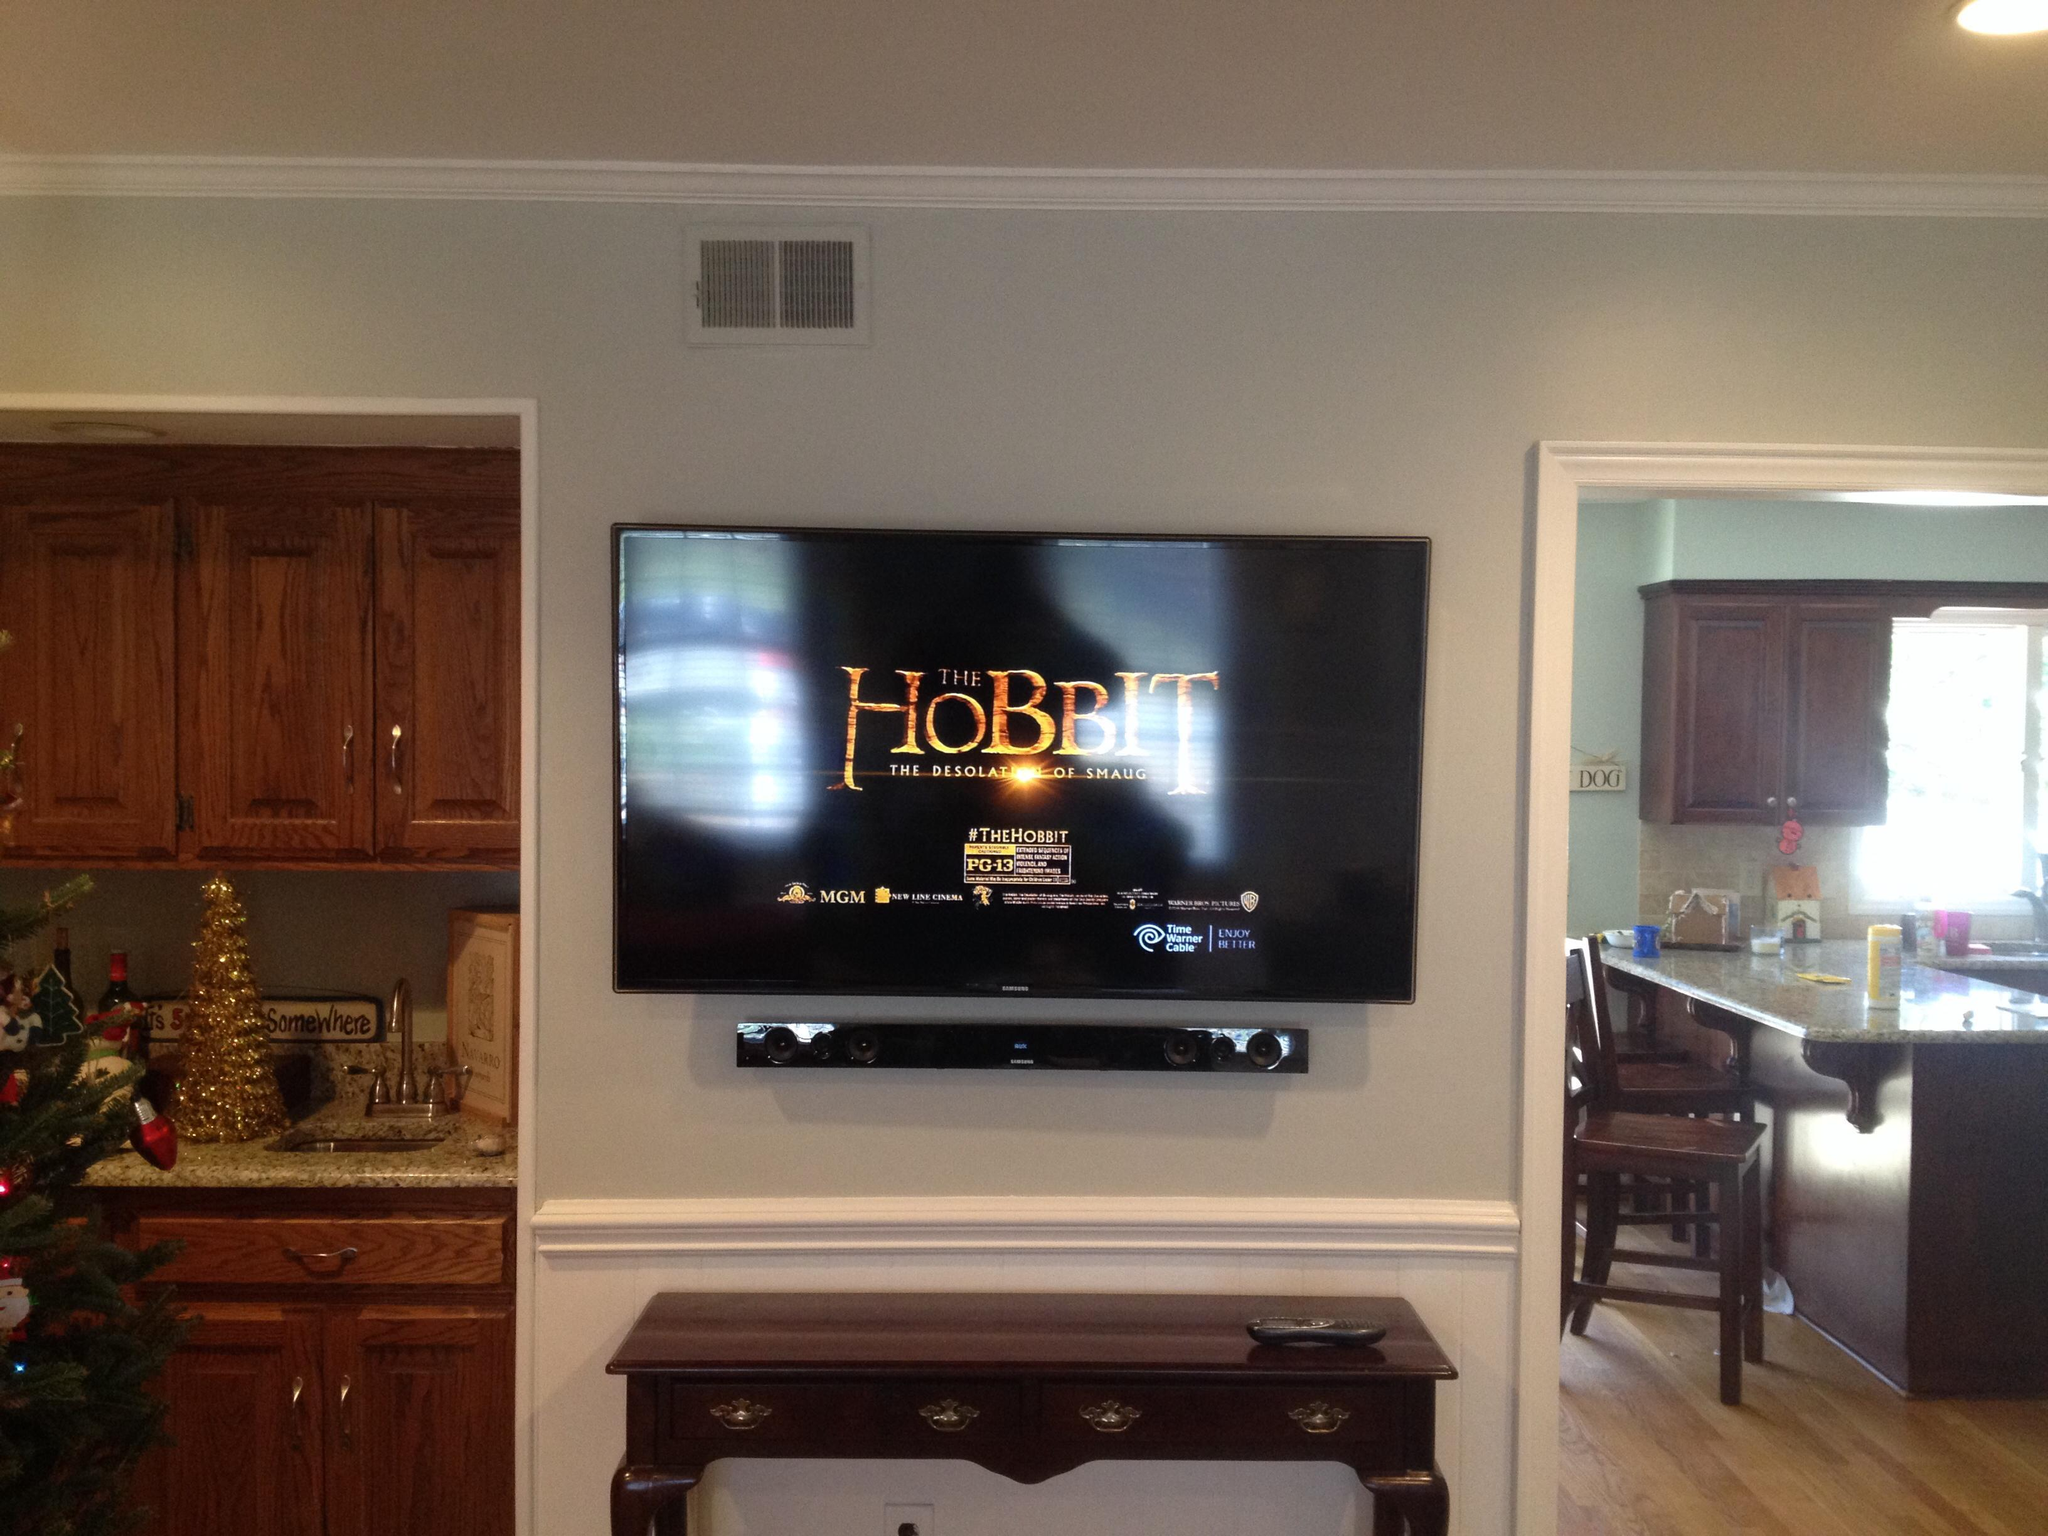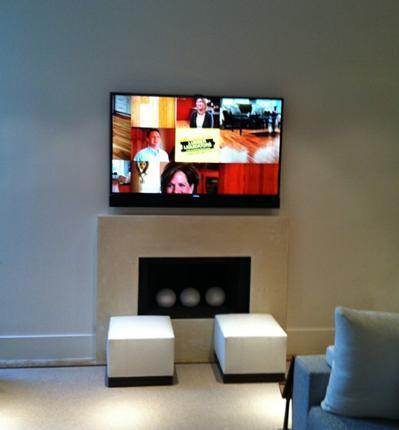The first image is the image on the left, the second image is the image on the right. Assess this claim about the two images: "There is nothing playing on at least one of the screens.". Correct or not? Answer yes or no. No. The first image is the image on the left, the second image is the image on the right. For the images displayed, is the sentence "At least one of the televisions is turned off." factually correct? Answer yes or no. No. 